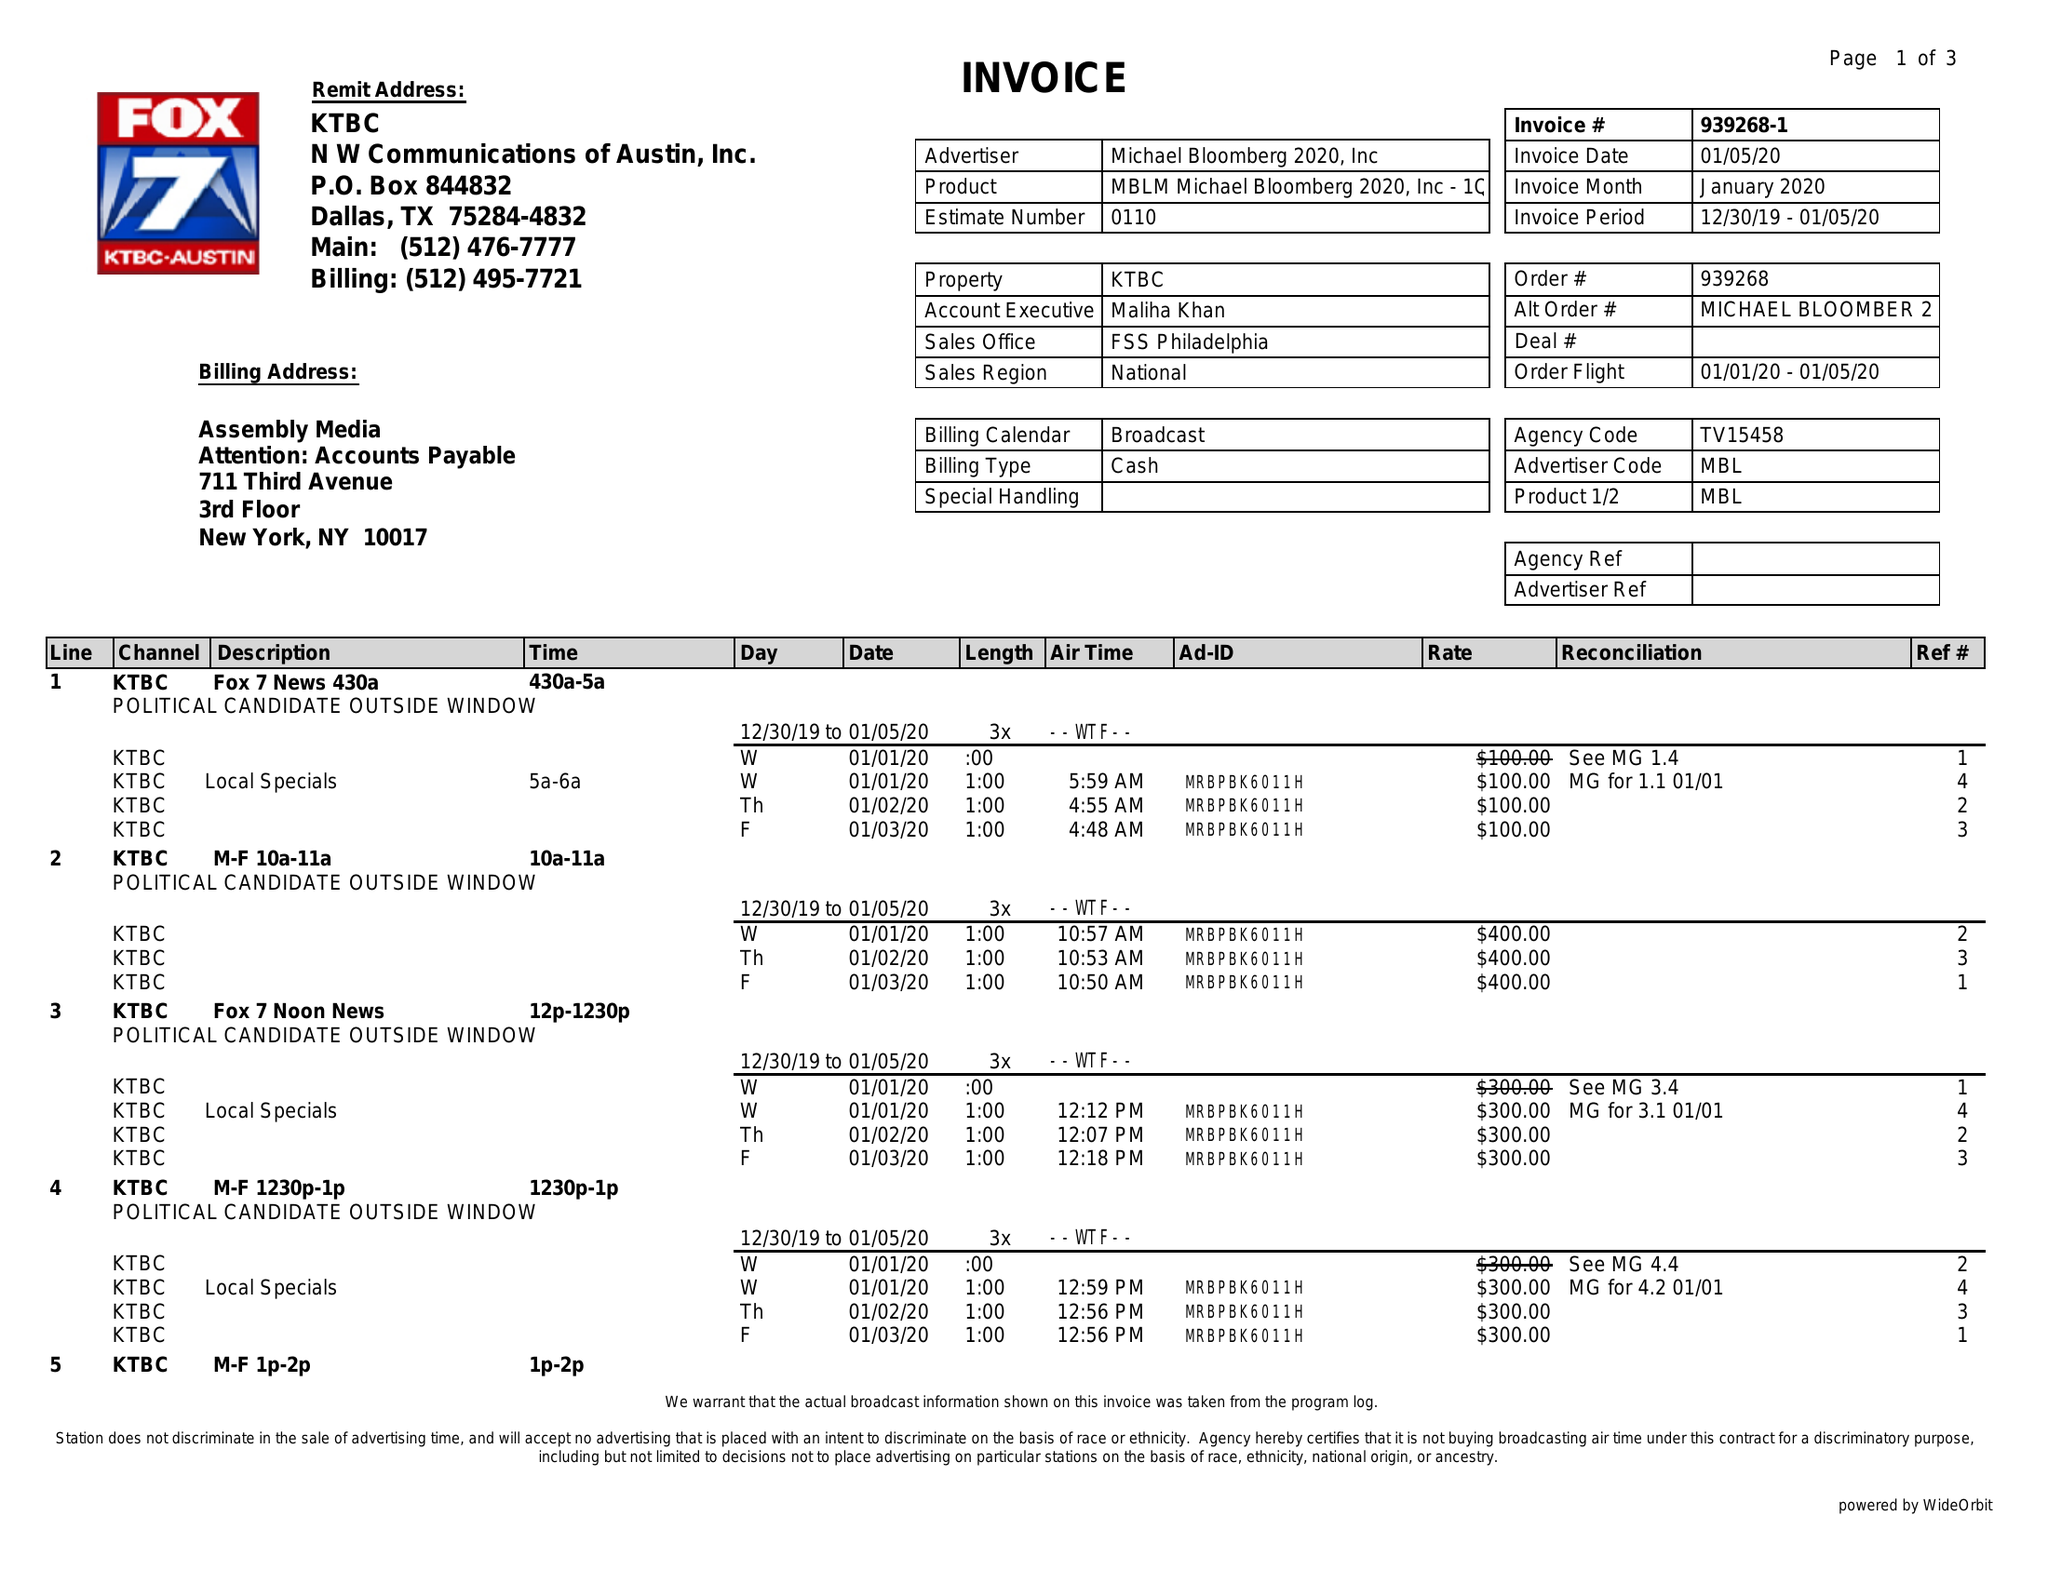What is the value for the flight_from?
Answer the question using a single word or phrase. 01/01/20 